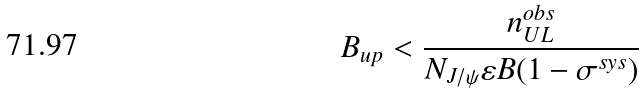<formula> <loc_0><loc_0><loc_500><loc_500>B _ { u p } < \frac { n ^ { o b s } _ { U L } } { N _ { J / \psi } { \varepsilon } B ( 1 - { \sigma } ^ { s y s } ) }</formula> 